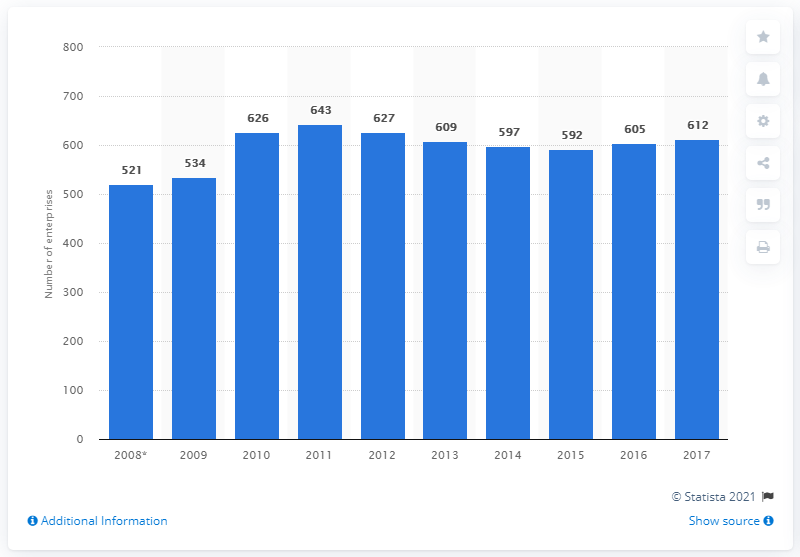Point out several critical features in this image. In 2017, there were 612 enterprises in the Czech Republic that manufactured domestic appliances. 